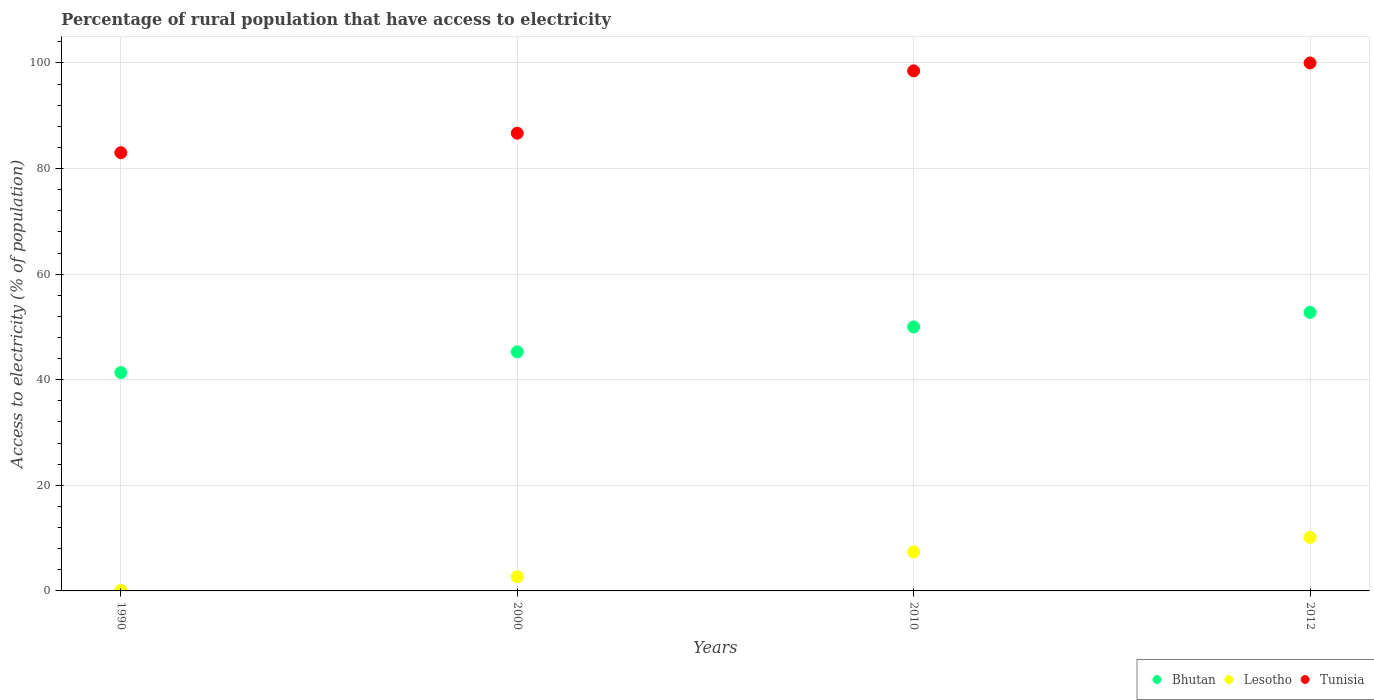How many different coloured dotlines are there?
Offer a very short reply. 3. Is the number of dotlines equal to the number of legend labels?
Provide a short and direct response. Yes. What is the percentage of rural population that have access to electricity in Lesotho in 2012?
Ensure brevity in your answer.  10.15. Across all years, what is the maximum percentage of rural population that have access to electricity in Lesotho?
Provide a short and direct response. 10.15. In which year was the percentage of rural population that have access to electricity in Bhutan maximum?
Give a very brief answer. 2012. In which year was the percentage of rural population that have access to electricity in Bhutan minimum?
Keep it short and to the point. 1990. What is the total percentage of rural population that have access to electricity in Lesotho in the graph?
Ensure brevity in your answer.  20.34. What is the difference between the percentage of rural population that have access to electricity in Bhutan in 1990 and that in 2010?
Offer a very short reply. -8.64. What is the difference between the percentage of rural population that have access to electricity in Bhutan in 2000 and the percentage of rural population that have access to electricity in Lesotho in 2010?
Offer a very short reply. 37.88. What is the average percentage of rural population that have access to electricity in Bhutan per year?
Make the answer very short. 47.35. In the year 1990, what is the difference between the percentage of rural population that have access to electricity in Bhutan and percentage of rural population that have access to electricity in Lesotho?
Provide a succinct answer. 41.26. What is the ratio of the percentage of rural population that have access to electricity in Lesotho in 1990 to that in 2010?
Make the answer very short. 0.01. Is the percentage of rural population that have access to electricity in Bhutan in 2010 less than that in 2012?
Your answer should be compact. Yes. What is the difference between the highest and the second highest percentage of rural population that have access to electricity in Bhutan?
Your response must be concise. 2.75. What is the difference between the highest and the lowest percentage of rural population that have access to electricity in Tunisia?
Keep it short and to the point. 17. Is it the case that in every year, the sum of the percentage of rural population that have access to electricity in Lesotho and percentage of rural population that have access to electricity in Tunisia  is greater than the percentage of rural population that have access to electricity in Bhutan?
Keep it short and to the point. Yes. Is the percentage of rural population that have access to electricity in Bhutan strictly greater than the percentage of rural population that have access to electricity in Lesotho over the years?
Offer a terse response. Yes. How many years are there in the graph?
Make the answer very short. 4. Are the values on the major ticks of Y-axis written in scientific E-notation?
Your response must be concise. No. Does the graph contain grids?
Provide a short and direct response. Yes. Where does the legend appear in the graph?
Ensure brevity in your answer.  Bottom right. How are the legend labels stacked?
Your answer should be very brief. Horizontal. What is the title of the graph?
Give a very brief answer. Percentage of rural population that have access to electricity. Does "Syrian Arab Republic" appear as one of the legend labels in the graph?
Keep it short and to the point. No. What is the label or title of the X-axis?
Give a very brief answer. Years. What is the label or title of the Y-axis?
Provide a short and direct response. Access to electricity (% of population). What is the Access to electricity (% of population) of Bhutan in 1990?
Make the answer very short. 41.36. What is the Access to electricity (% of population) of Lesotho in 1990?
Your response must be concise. 0.1. What is the Access to electricity (% of population) of Bhutan in 2000?
Offer a very short reply. 45.28. What is the Access to electricity (% of population) in Lesotho in 2000?
Ensure brevity in your answer.  2.68. What is the Access to electricity (% of population) in Tunisia in 2000?
Offer a very short reply. 86.7. What is the Access to electricity (% of population) of Bhutan in 2010?
Your answer should be very brief. 50. What is the Access to electricity (% of population) of Lesotho in 2010?
Make the answer very short. 7.4. What is the Access to electricity (% of population) of Tunisia in 2010?
Provide a short and direct response. 98.5. What is the Access to electricity (% of population) of Bhutan in 2012?
Offer a very short reply. 52.75. What is the Access to electricity (% of population) in Lesotho in 2012?
Ensure brevity in your answer.  10.15. Across all years, what is the maximum Access to electricity (% of population) of Bhutan?
Provide a succinct answer. 52.75. Across all years, what is the maximum Access to electricity (% of population) of Lesotho?
Provide a short and direct response. 10.15. Across all years, what is the maximum Access to electricity (% of population) in Tunisia?
Keep it short and to the point. 100. Across all years, what is the minimum Access to electricity (% of population) in Bhutan?
Provide a succinct answer. 41.36. Across all years, what is the minimum Access to electricity (% of population) of Tunisia?
Ensure brevity in your answer.  83. What is the total Access to electricity (% of population) of Bhutan in the graph?
Your answer should be compact. 189.4. What is the total Access to electricity (% of population) of Lesotho in the graph?
Offer a very short reply. 20.34. What is the total Access to electricity (% of population) in Tunisia in the graph?
Your answer should be compact. 368.2. What is the difference between the Access to electricity (% of population) in Bhutan in 1990 and that in 2000?
Ensure brevity in your answer.  -3.92. What is the difference between the Access to electricity (% of population) of Lesotho in 1990 and that in 2000?
Provide a succinct answer. -2.58. What is the difference between the Access to electricity (% of population) in Bhutan in 1990 and that in 2010?
Your answer should be compact. -8.64. What is the difference between the Access to electricity (% of population) in Tunisia in 1990 and that in 2010?
Provide a succinct answer. -15.5. What is the difference between the Access to electricity (% of population) in Bhutan in 1990 and that in 2012?
Ensure brevity in your answer.  -11.39. What is the difference between the Access to electricity (% of population) in Lesotho in 1990 and that in 2012?
Provide a short and direct response. -10.05. What is the difference between the Access to electricity (% of population) in Bhutan in 2000 and that in 2010?
Provide a short and direct response. -4.72. What is the difference between the Access to electricity (% of population) in Lesotho in 2000 and that in 2010?
Offer a very short reply. -4.72. What is the difference between the Access to electricity (% of population) in Tunisia in 2000 and that in 2010?
Provide a short and direct response. -11.8. What is the difference between the Access to electricity (% of population) of Bhutan in 2000 and that in 2012?
Your answer should be very brief. -7.47. What is the difference between the Access to electricity (% of population) in Lesotho in 2000 and that in 2012?
Keep it short and to the point. -7.47. What is the difference between the Access to electricity (% of population) in Bhutan in 2010 and that in 2012?
Provide a succinct answer. -2.75. What is the difference between the Access to electricity (% of population) of Lesotho in 2010 and that in 2012?
Give a very brief answer. -2.75. What is the difference between the Access to electricity (% of population) of Bhutan in 1990 and the Access to electricity (% of population) of Lesotho in 2000?
Give a very brief answer. 38.68. What is the difference between the Access to electricity (% of population) in Bhutan in 1990 and the Access to electricity (% of population) in Tunisia in 2000?
Keep it short and to the point. -45.34. What is the difference between the Access to electricity (% of population) in Lesotho in 1990 and the Access to electricity (% of population) in Tunisia in 2000?
Your answer should be compact. -86.6. What is the difference between the Access to electricity (% of population) in Bhutan in 1990 and the Access to electricity (% of population) in Lesotho in 2010?
Provide a succinct answer. 33.96. What is the difference between the Access to electricity (% of population) of Bhutan in 1990 and the Access to electricity (% of population) of Tunisia in 2010?
Offer a terse response. -57.14. What is the difference between the Access to electricity (% of population) of Lesotho in 1990 and the Access to electricity (% of population) of Tunisia in 2010?
Offer a terse response. -98.4. What is the difference between the Access to electricity (% of population) of Bhutan in 1990 and the Access to electricity (% of population) of Lesotho in 2012?
Provide a succinct answer. 31.21. What is the difference between the Access to electricity (% of population) of Bhutan in 1990 and the Access to electricity (% of population) of Tunisia in 2012?
Ensure brevity in your answer.  -58.64. What is the difference between the Access to electricity (% of population) of Lesotho in 1990 and the Access to electricity (% of population) of Tunisia in 2012?
Your answer should be compact. -99.9. What is the difference between the Access to electricity (% of population) in Bhutan in 2000 and the Access to electricity (% of population) in Lesotho in 2010?
Offer a terse response. 37.88. What is the difference between the Access to electricity (% of population) of Bhutan in 2000 and the Access to electricity (% of population) of Tunisia in 2010?
Your response must be concise. -53.22. What is the difference between the Access to electricity (% of population) in Lesotho in 2000 and the Access to electricity (% of population) in Tunisia in 2010?
Provide a succinct answer. -95.82. What is the difference between the Access to electricity (% of population) in Bhutan in 2000 and the Access to electricity (% of population) in Lesotho in 2012?
Provide a succinct answer. 35.13. What is the difference between the Access to electricity (% of population) in Bhutan in 2000 and the Access to electricity (% of population) in Tunisia in 2012?
Your answer should be compact. -54.72. What is the difference between the Access to electricity (% of population) of Lesotho in 2000 and the Access to electricity (% of population) of Tunisia in 2012?
Your answer should be compact. -97.32. What is the difference between the Access to electricity (% of population) in Bhutan in 2010 and the Access to electricity (% of population) in Lesotho in 2012?
Offer a terse response. 39.85. What is the difference between the Access to electricity (% of population) in Lesotho in 2010 and the Access to electricity (% of population) in Tunisia in 2012?
Your answer should be compact. -92.6. What is the average Access to electricity (% of population) in Bhutan per year?
Provide a succinct answer. 47.35. What is the average Access to electricity (% of population) in Lesotho per year?
Your response must be concise. 5.08. What is the average Access to electricity (% of population) in Tunisia per year?
Ensure brevity in your answer.  92.05. In the year 1990, what is the difference between the Access to electricity (% of population) of Bhutan and Access to electricity (% of population) of Lesotho?
Provide a succinct answer. 41.26. In the year 1990, what is the difference between the Access to electricity (% of population) of Bhutan and Access to electricity (% of population) of Tunisia?
Make the answer very short. -41.64. In the year 1990, what is the difference between the Access to electricity (% of population) of Lesotho and Access to electricity (% of population) of Tunisia?
Provide a short and direct response. -82.9. In the year 2000, what is the difference between the Access to electricity (% of population) of Bhutan and Access to electricity (% of population) of Lesotho?
Provide a short and direct response. 42.6. In the year 2000, what is the difference between the Access to electricity (% of population) of Bhutan and Access to electricity (% of population) of Tunisia?
Give a very brief answer. -41.42. In the year 2000, what is the difference between the Access to electricity (% of population) of Lesotho and Access to electricity (% of population) of Tunisia?
Offer a terse response. -84.02. In the year 2010, what is the difference between the Access to electricity (% of population) in Bhutan and Access to electricity (% of population) in Lesotho?
Your response must be concise. 42.6. In the year 2010, what is the difference between the Access to electricity (% of population) in Bhutan and Access to electricity (% of population) in Tunisia?
Provide a succinct answer. -48.5. In the year 2010, what is the difference between the Access to electricity (% of population) of Lesotho and Access to electricity (% of population) of Tunisia?
Offer a terse response. -91.1. In the year 2012, what is the difference between the Access to electricity (% of population) of Bhutan and Access to electricity (% of population) of Lesotho?
Make the answer very short. 42.6. In the year 2012, what is the difference between the Access to electricity (% of population) in Bhutan and Access to electricity (% of population) in Tunisia?
Ensure brevity in your answer.  -47.25. In the year 2012, what is the difference between the Access to electricity (% of population) of Lesotho and Access to electricity (% of population) of Tunisia?
Your response must be concise. -89.85. What is the ratio of the Access to electricity (% of population) in Bhutan in 1990 to that in 2000?
Keep it short and to the point. 0.91. What is the ratio of the Access to electricity (% of population) in Lesotho in 1990 to that in 2000?
Make the answer very short. 0.04. What is the ratio of the Access to electricity (% of population) of Tunisia in 1990 to that in 2000?
Make the answer very short. 0.96. What is the ratio of the Access to electricity (% of population) of Bhutan in 1990 to that in 2010?
Your answer should be compact. 0.83. What is the ratio of the Access to electricity (% of population) in Lesotho in 1990 to that in 2010?
Your answer should be compact. 0.01. What is the ratio of the Access to electricity (% of population) in Tunisia in 1990 to that in 2010?
Your answer should be very brief. 0.84. What is the ratio of the Access to electricity (% of population) in Bhutan in 1990 to that in 2012?
Make the answer very short. 0.78. What is the ratio of the Access to electricity (% of population) in Lesotho in 1990 to that in 2012?
Offer a very short reply. 0.01. What is the ratio of the Access to electricity (% of population) in Tunisia in 1990 to that in 2012?
Make the answer very short. 0.83. What is the ratio of the Access to electricity (% of population) in Bhutan in 2000 to that in 2010?
Offer a terse response. 0.91. What is the ratio of the Access to electricity (% of population) in Lesotho in 2000 to that in 2010?
Provide a short and direct response. 0.36. What is the ratio of the Access to electricity (% of population) in Tunisia in 2000 to that in 2010?
Make the answer very short. 0.88. What is the ratio of the Access to electricity (% of population) in Bhutan in 2000 to that in 2012?
Provide a succinct answer. 0.86. What is the ratio of the Access to electricity (% of population) in Lesotho in 2000 to that in 2012?
Your answer should be very brief. 0.26. What is the ratio of the Access to electricity (% of population) in Tunisia in 2000 to that in 2012?
Your answer should be very brief. 0.87. What is the ratio of the Access to electricity (% of population) in Bhutan in 2010 to that in 2012?
Offer a terse response. 0.95. What is the ratio of the Access to electricity (% of population) of Lesotho in 2010 to that in 2012?
Your response must be concise. 0.73. What is the ratio of the Access to electricity (% of population) of Tunisia in 2010 to that in 2012?
Ensure brevity in your answer.  0.98. What is the difference between the highest and the second highest Access to electricity (% of population) of Bhutan?
Offer a terse response. 2.75. What is the difference between the highest and the second highest Access to electricity (% of population) in Lesotho?
Your response must be concise. 2.75. What is the difference between the highest and the lowest Access to electricity (% of population) in Bhutan?
Ensure brevity in your answer.  11.39. What is the difference between the highest and the lowest Access to electricity (% of population) of Lesotho?
Offer a terse response. 10.05. 